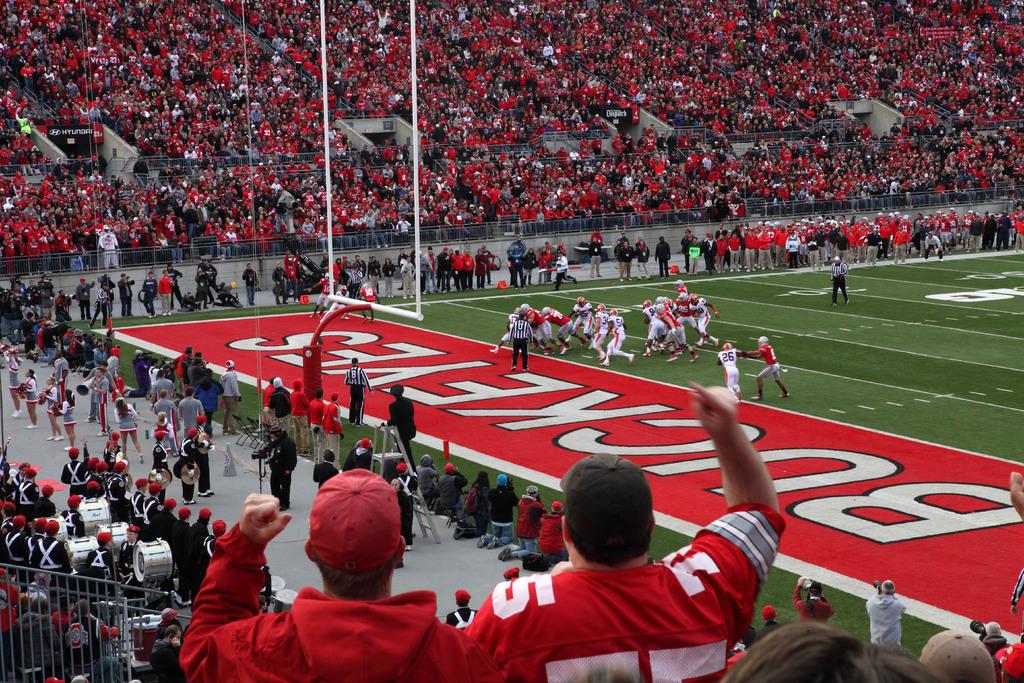What is one of the teams playing here?
Make the answer very short. Buckeyes. What team is playing?
Make the answer very short. Buckeyes. 